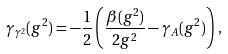<formula> <loc_0><loc_0><loc_500><loc_500>\gamma _ { \gamma ^ { 2 } } ( g ^ { 2 } ) = - \frac { 1 } { 2 } \left ( \frac { \beta ( g ^ { 2 } ) } { 2 g ^ { 2 } } - \gamma _ { A } ( g ^ { 2 } ) \right ) \, ,</formula> 